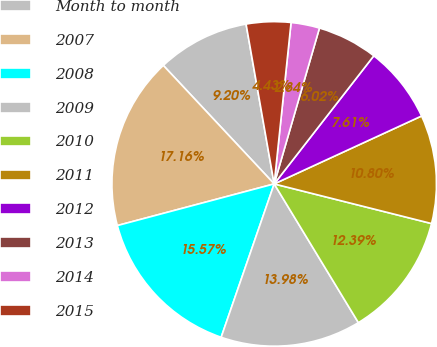Convert chart. <chart><loc_0><loc_0><loc_500><loc_500><pie_chart><fcel>Month to month<fcel>2007<fcel>2008<fcel>2009<fcel>2010<fcel>2011<fcel>2012<fcel>2013<fcel>2014<fcel>2015<nl><fcel>9.2%<fcel>17.16%<fcel>15.57%<fcel>13.98%<fcel>12.39%<fcel>10.8%<fcel>7.61%<fcel>6.02%<fcel>2.84%<fcel>4.43%<nl></chart> 